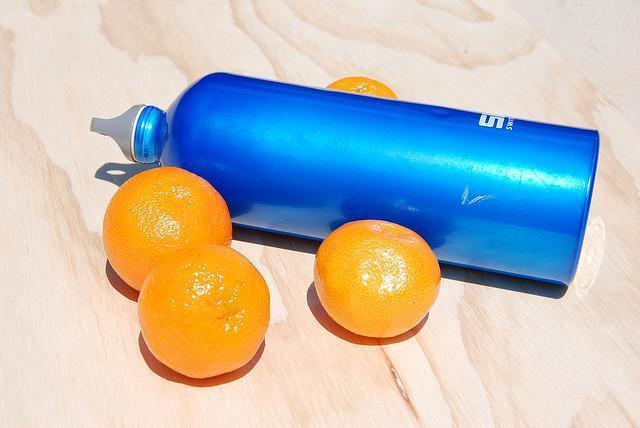How many pieces of fruit are visible?
Give a very brief answer. 4. How many oranges can be seen?
Give a very brief answer. 3. How many remotes are there?
Give a very brief answer. 0. 